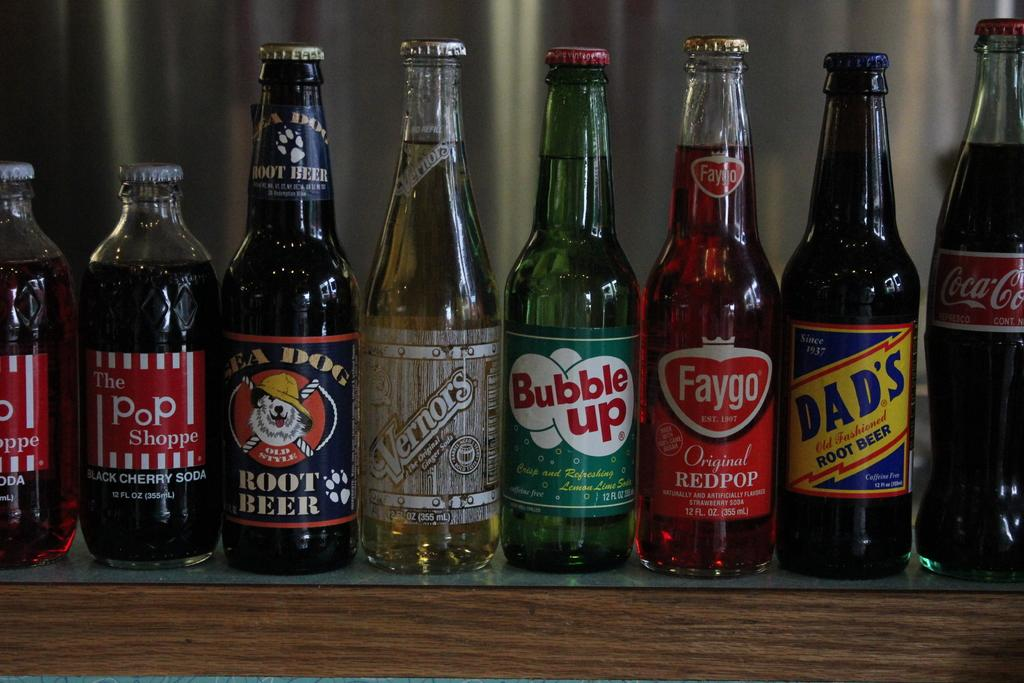<image>
Write a terse but informative summary of the picture. A line up of pop bottles on a shelf Bubble up is in the center. 